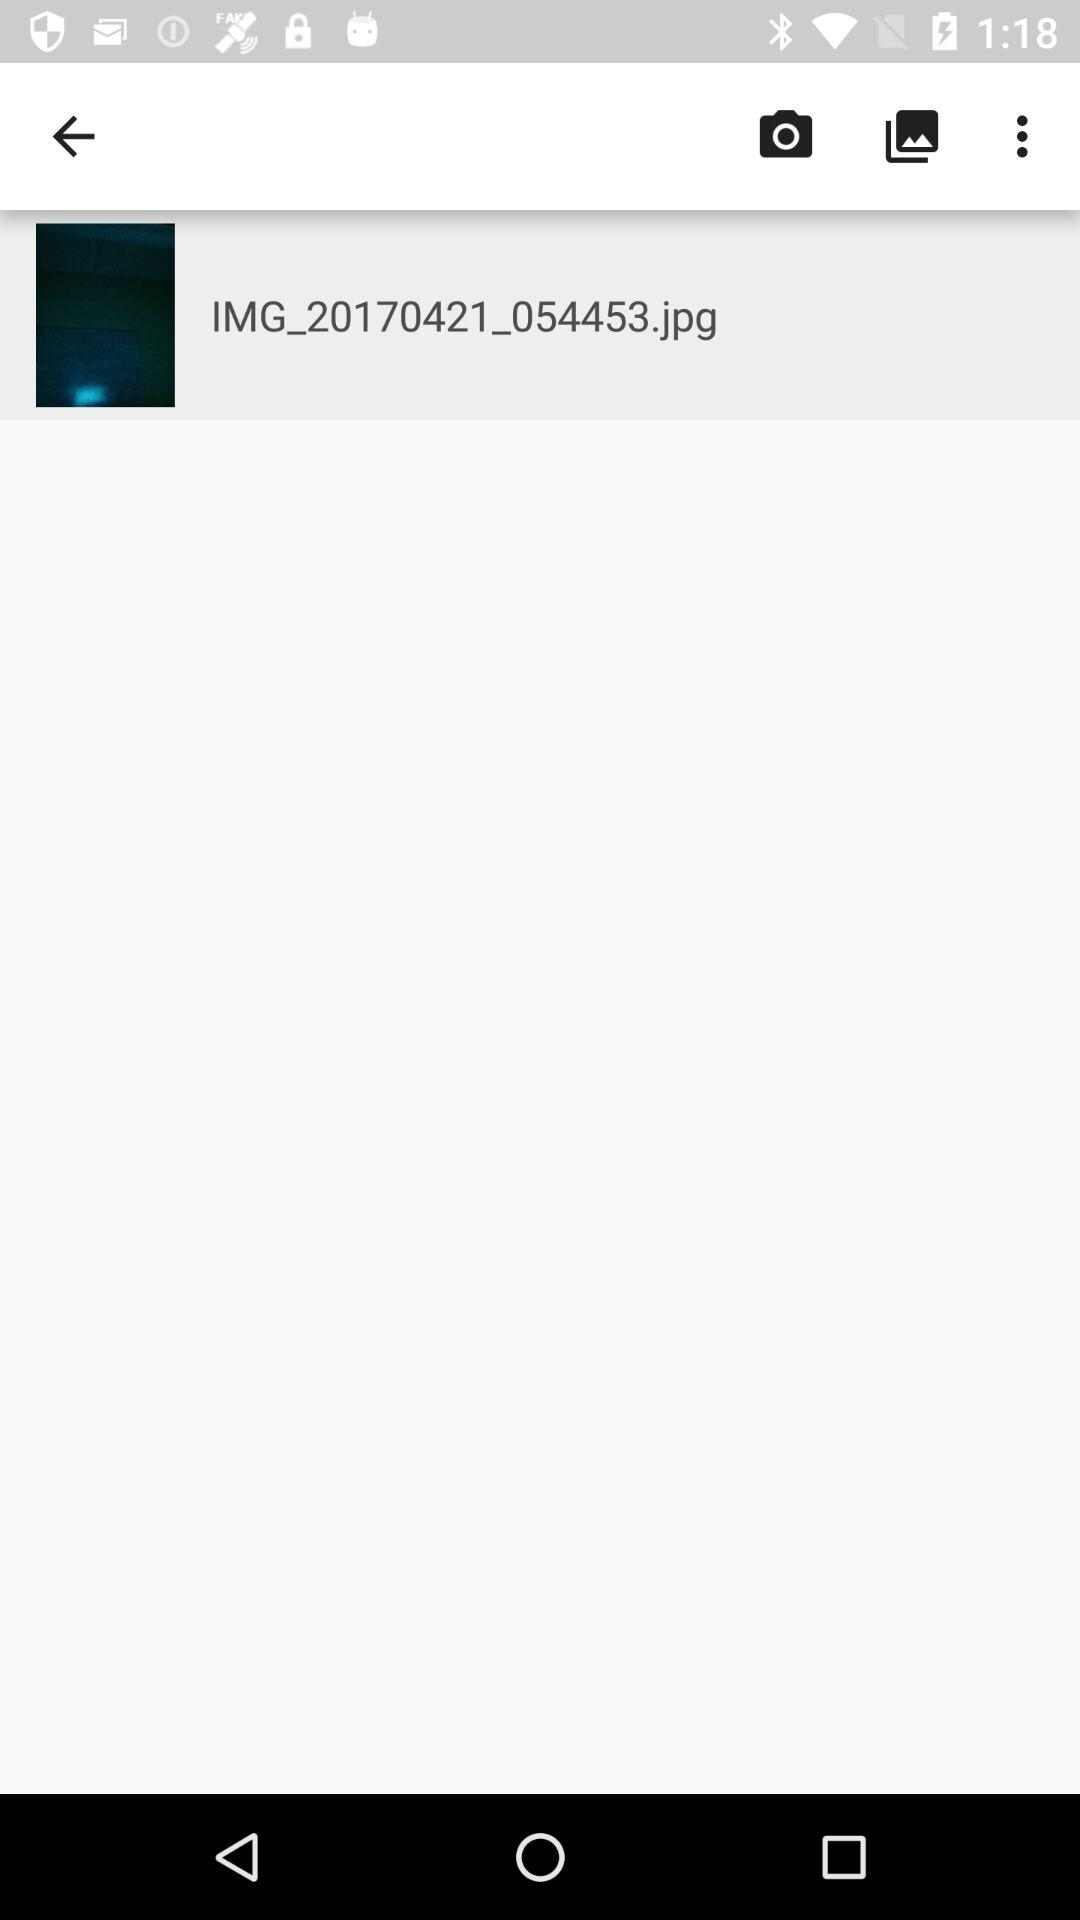What is the size of the images in megabytes?
When the provided information is insufficient, respond with <no answer>. <no answer> 